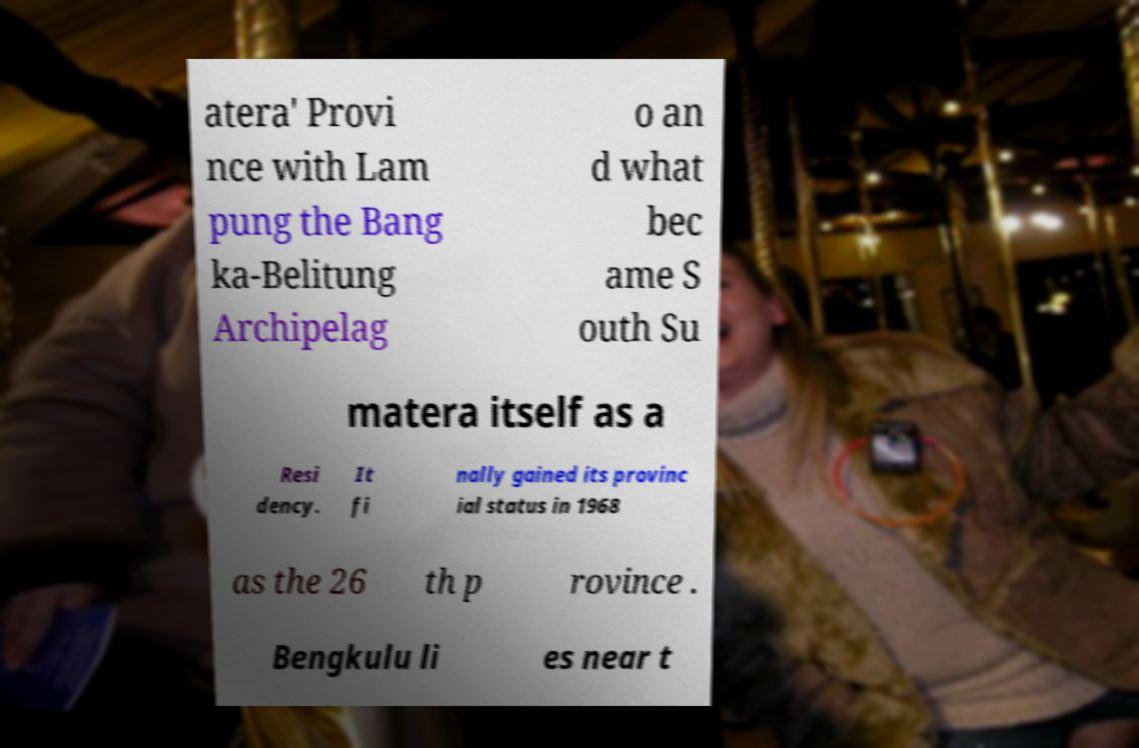I need the written content from this picture converted into text. Can you do that? atera' Provi nce with Lam pung the Bang ka-Belitung Archipelag o an d what bec ame S outh Su matera itself as a Resi dency. It fi nally gained its provinc ial status in 1968 as the 26 th p rovince . Bengkulu li es near t 